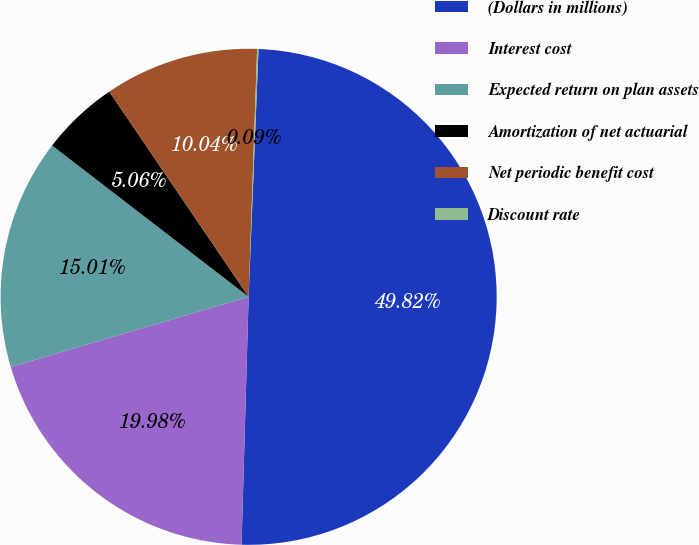Convert chart to OTSL. <chart><loc_0><loc_0><loc_500><loc_500><pie_chart><fcel>(Dollars in millions)<fcel>Interest cost<fcel>Expected return on plan assets<fcel>Amortization of net actuarial<fcel>Net periodic benefit cost<fcel>Discount rate<nl><fcel>49.82%<fcel>19.98%<fcel>15.01%<fcel>5.06%<fcel>10.04%<fcel>0.09%<nl></chart> 